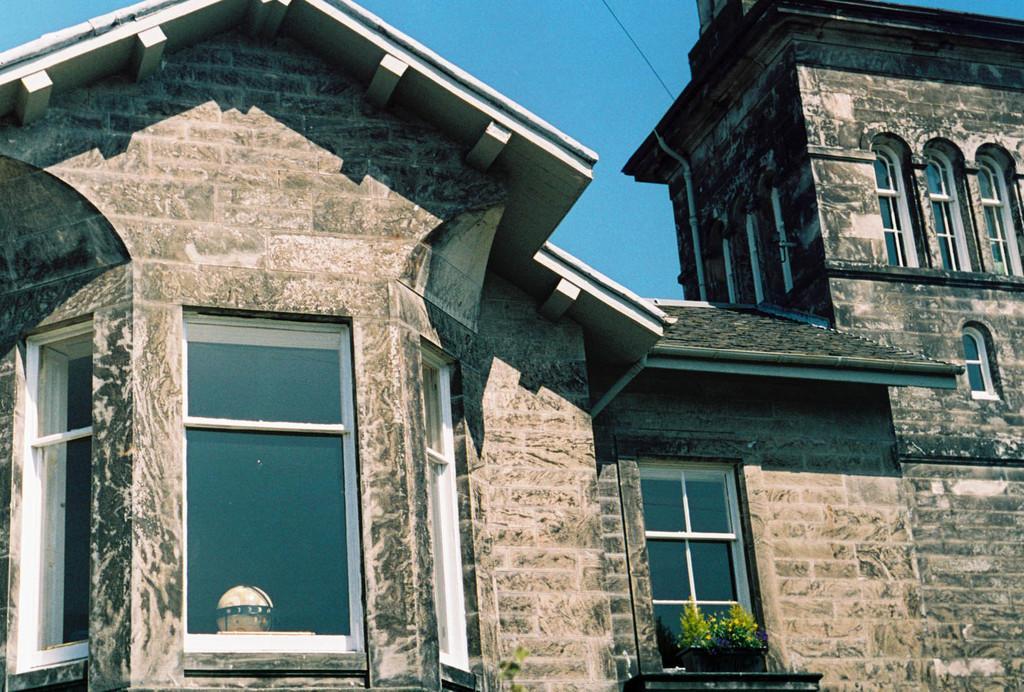How would you summarize this image in a sentence or two? In this image we can see a building with windows, two plants, roof. In the background we can see the sky. 